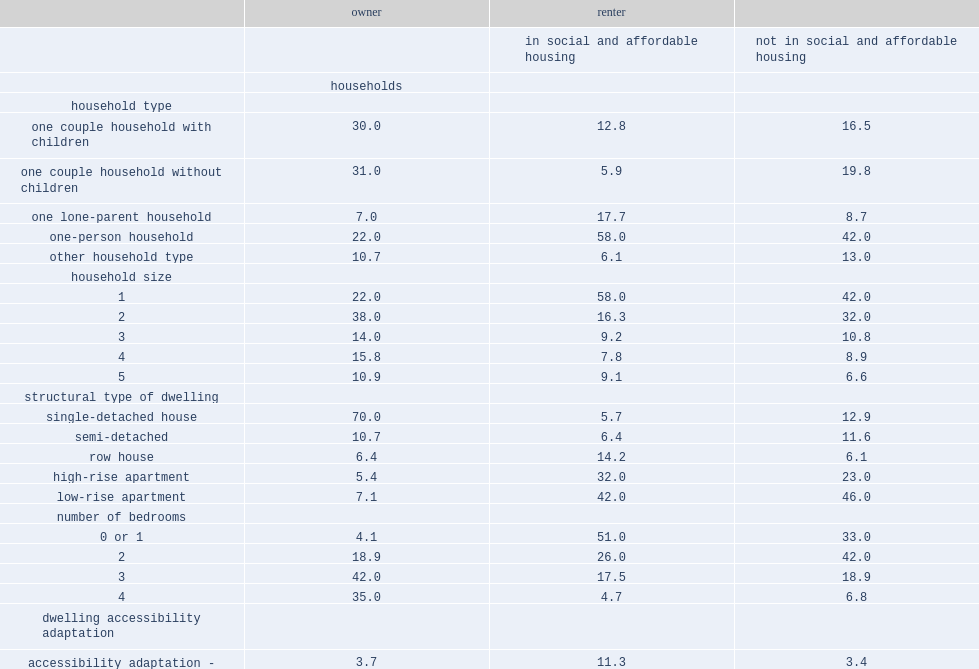Help me parse the entirety of this table. {'header': ['', 'owner', 'renter', ''], 'rows': [['', '', 'in social and affordable housing', 'not in social and affordable housing'], ['', 'households', '', ''], ['household type', '', '', ''], ['one couple household with children', '30.0', '12.8', '16.5'], ['one couple household without children', '31.0', '5.9', '19.8'], ['one lone-parent household', '7.0', '17.7', '8.7'], ['one-person household', '22.0', '58.0', '42.0'], ['other household type', '10.7', '6.1', '13.0'], ['household size', '', '', ''], ['1', '22.0', '58.0', '42.0'], ['2', '38.0', '16.3', '32.0'], ['3', '14.0', '9.2', '10.8'], ['4', '15.8', '7.8', '8.9'], ['5', '10.9', '9.1', '6.6'], ['structural type of dwelling', '', '', ''], ['single-detached house', '70.0', '5.7', '12.9'], ['semi-detached', '10.7', '6.4', '11.6'], ['row house', '6.4', '14.2', '6.1'], ['high-rise apartment', '5.4', '32.0', '23.0'], ['low-rise apartment', '7.1', '42.0', '46.0'], ['number of bedrooms', '', '', ''], ['0 or 1', '4.1', '51.0', '33.0'], ['2', '18.9', '26.0', '42.0'], ['3', '42.0', '17.5', '18.9'], ['4', '35.0', '4.7', '6.8'], ['dwelling accessibility adaptation', '', '', ''], ['accessibility adaptation - needs met', '3.7', '11.3', '3.4'], ['accessibility adaptation - needs not met', '3.2', '7.2', '2.8'], ['accessibility adaptation not required', '93.1', '81.4', '93.8']]} What is the most popular type of renter households in social and affordable housing? One-person household. What percent of renters that were not in social and affordable housing were living in a household of two or more persons? 58.3. What percent of canadian renter households in social and affordable housing were lone-parent households? 17.7. What percent of lone-parent households was for owner? 7.0. What percent of renter households in social and affordable housing were living in apartments? 74. Which type of renter household in social and affordable housing has more renters? low-rise apartments or high-rise apartments ? Low-rise apartment. Which type of renter household not in social and affordable housing has more renters? low-rise apartments or high-rise apartments ? Low-rise apartment. What type of households is the most common households for owners? Single-detached house semi-detached. Which type of people were more likely to live in apartments? renters or owners? Renter. What percent of renters not in social and affordable housing needed adaptations. 6.2. 